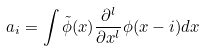<formula> <loc_0><loc_0><loc_500><loc_500>a _ { i } = \int \tilde { \phi } ( x ) \frac { \partial ^ { l } } { \partial x ^ { l } } \phi ( x - i ) d x</formula> 